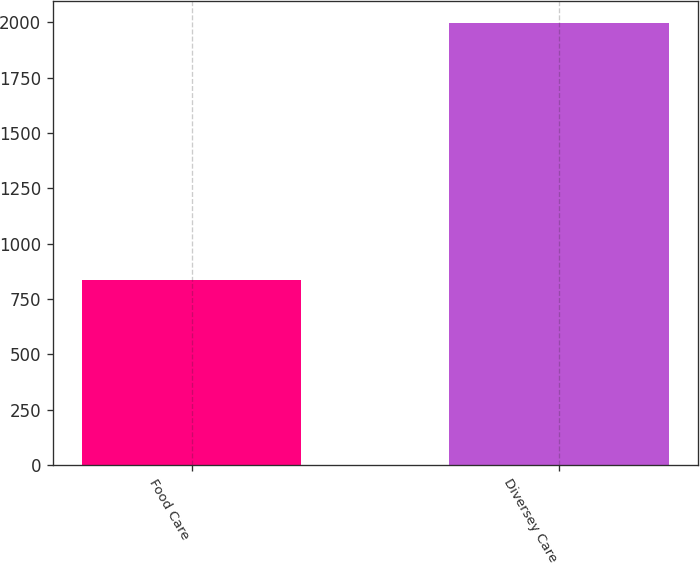Convert chart to OTSL. <chart><loc_0><loc_0><loc_500><loc_500><bar_chart><fcel>Food Care<fcel>Diversey Care<nl><fcel>833.7<fcel>1994.1<nl></chart> 